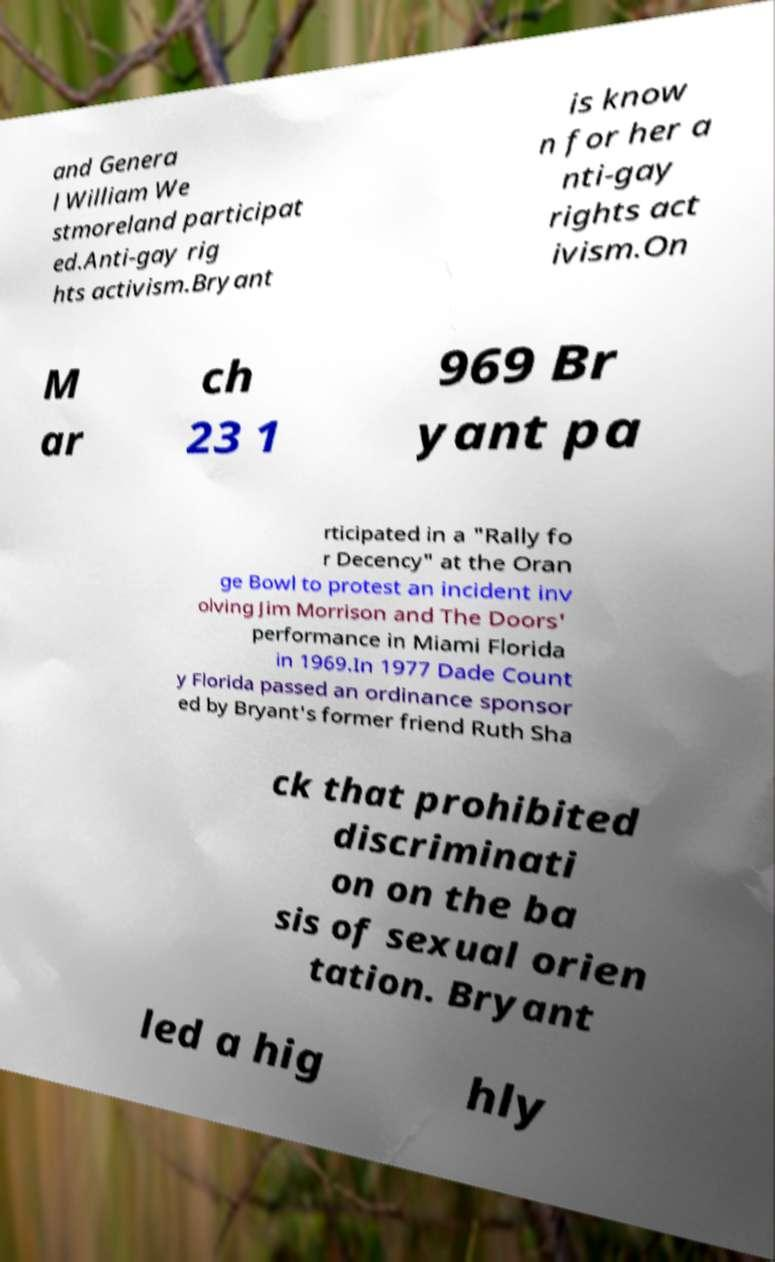Could you assist in decoding the text presented in this image and type it out clearly? and Genera l William We stmoreland participat ed.Anti-gay rig hts activism.Bryant is know n for her a nti-gay rights act ivism.On M ar ch 23 1 969 Br yant pa rticipated in a "Rally fo r Decency" at the Oran ge Bowl to protest an incident inv olving Jim Morrison and The Doors' performance in Miami Florida in 1969.In 1977 Dade Count y Florida passed an ordinance sponsor ed by Bryant's former friend Ruth Sha ck that prohibited discriminati on on the ba sis of sexual orien tation. Bryant led a hig hly 